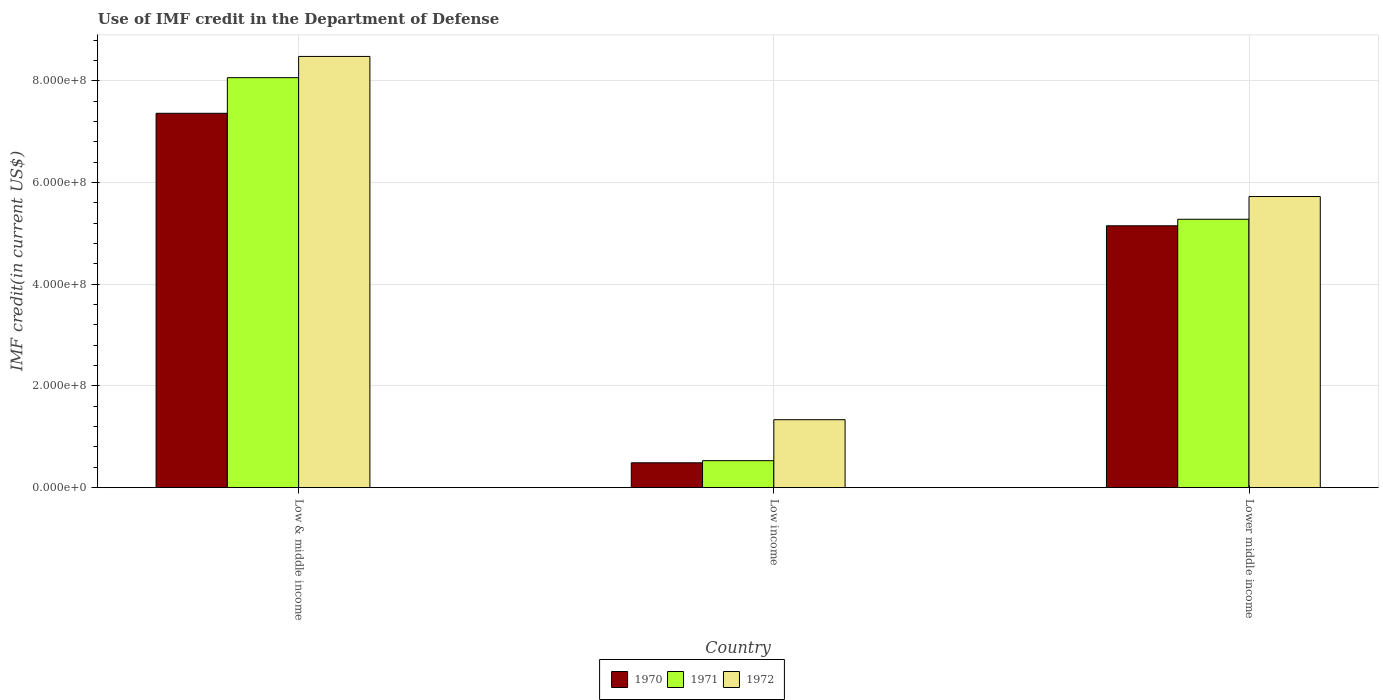Are the number of bars on each tick of the X-axis equal?
Your answer should be very brief. Yes. How many bars are there on the 3rd tick from the left?
Provide a short and direct response. 3. What is the label of the 1st group of bars from the left?
Make the answer very short. Low & middle income. In how many cases, is the number of bars for a given country not equal to the number of legend labels?
Provide a short and direct response. 0. What is the IMF credit in the Department of Defense in 1970 in Low income?
Keep it short and to the point. 4.88e+07. Across all countries, what is the maximum IMF credit in the Department of Defense in 1971?
Your response must be concise. 8.06e+08. Across all countries, what is the minimum IMF credit in the Department of Defense in 1972?
Your answer should be compact. 1.34e+08. In which country was the IMF credit in the Department of Defense in 1971 maximum?
Make the answer very short. Low & middle income. In which country was the IMF credit in the Department of Defense in 1970 minimum?
Ensure brevity in your answer.  Low income. What is the total IMF credit in the Department of Defense in 1972 in the graph?
Ensure brevity in your answer.  1.55e+09. What is the difference between the IMF credit in the Department of Defense in 1970 in Low & middle income and that in Lower middle income?
Offer a terse response. 2.21e+08. What is the difference between the IMF credit in the Department of Defense in 1971 in Low income and the IMF credit in the Department of Defense in 1970 in Low & middle income?
Your answer should be compact. -6.83e+08. What is the average IMF credit in the Department of Defense in 1972 per country?
Make the answer very short. 5.18e+08. What is the difference between the IMF credit in the Department of Defense of/in 1971 and IMF credit in the Department of Defense of/in 1972 in Low & middle income?
Your answer should be compact. -4.18e+07. What is the ratio of the IMF credit in the Department of Defense in 1970 in Low income to that in Lower middle income?
Your response must be concise. 0.09. Is the IMF credit in the Department of Defense in 1971 in Low income less than that in Lower middle income?
Keep it short and to the point. Yes. Is the difference between the IMF credit in the Department of Defense in 1971 in Low income and Lower middle income greater than the difference between the IMF credit in the Department of Defense in 1972 in Low income and Lower middle income?
Keep it short and to the point. No. What is the difference between the highest and the second highest IMF credit in the Department of Defense in 1972?
Ensure brevity in your answer.  -7.14e+08. What is the difference between the highest and the lowest IMF credit in the Department of Defense in 1970?
Give a very brief answer. 6.87e+08. In how many countries, is the IMF credit in the Department of Defense in 1970 greater than the average IMF credit in the Department of Defense in 1970 taken over all countries?
Give a very brief answer. 2. Is the sum of the IMF credit in the Department of Defense in 1970 in Low income and Lower middle income greater than the maximum IMF credit in the Department of Defense in 1972 across all countries?
Your answer should be compact. No. What does the 2nd bar from the right in Lower middle income represents?
Offer a terse response. 1971. Are all the bars in the graph horizontal?
Keep it short and to the point. No. Are the values on the major ticks of Y-axis written in scientific E-notation?
Give a very brief answer. Yes. Does the graph contain any zero values?
Offer a terse response. No. Where does the legend appear in the graph?
Your answer should be very brief. Bottom center. What is the title of the graph?
Provide a succinct answer. Use of IMF credit in the Department of Defense. What is the label or title of the Y-axis?
Keep it short and to the point. IMF credit(in current US$). What is the IMF credit(in current US$) in 1970 in Low & middle income?
Offer a terse response. 7.36e+08. What is the IMF credit(in current US$) in 1971 in Low & middle income?
Offer a very short reply. 8.06e+08. What is the IMF credit(in current US$) of 1972 in Low & middle income?
Your answer should be very brief. 8.48e+08. What is the IMF credit(in current US$) in 1970 in Low income?
Offer a terse response. 4.88e+07. What is the IMF credit(in current US$) of 1971 in Low income?
Keep it short and to the point. 5.30e+07. What is the IMF credit(in current US$) of 1972 in Low income?
Ensure brevity in your answer.  1.34e+08. What is the IMF credit(in current US$) of 1970 in Lower middle income?
Your answer should be compact. 5.15e+08. What is the IMF credit(in current US$) of 1971 in Lower middle income?
Give a very brief answer. 5.28e+08. What is the IMF credit(in current US$) of 1972 in Lower middle income?
Offer a terse response. 5.73e+08. Across all countries, what is the maximum IMF credit(in current US$) in 1970?
Ensure brevity in your answer.  7.36e+08. Across all countries, what is the maximum IMF credit(in current US$) of 1971?
Provide a succinct answer. 8.06e+08. Across all countries, what is the maximum IMF credit(in current US$) of 1972?
Your answer should be very brief. 8.48e+08. Across all countries, what is the minimum IMF credit(in current US$) of 1970?
Offer a terse response. 4.88e+07. Across all countries, what is the minimum IMF credit(in current US$) of 1971?
Your answer should be compact. 5.30e+07. Across all countries, what is the minimum IMF credit(in current US$) of 1972?
Your answer should be compact. 1.34e+08. What is the total IMF credit(in current US$) of 1970 in the graph?
Ensure brevity in your answer.  1.30e+09. What is the total IMF credit(in current US$) of 1971 in the graph?
Provide a succinct answer. 1.39e+09. What is the total IMF credit(in current US$) in 1972 in the graph?
Provide a succinct answer. 1.55e+09. What is the difference between the IMF credit(in current US$) of 1970 in Low & middle income and that in Low income?
Your answer should be very brief. 6.87e+08. What is the difference between the IMF credit(in current US$) in 1971 in Low & middle income and that in Low income?
Keep it short and to the point. 7.53e+08. What is the difference between the IMF credit(in current US$) of 1972 in Low & middle income and that in Low income?
Offer a terse response. 7.14e+08. What is the difference between the IMF credit(in current US$) in 1970 in Low & middle income and that in Lower middle income?
Make the answer very short. 2.21e+08. What is the difference between the IMF credit(in current US$) of 1971 in Low & middle income and that in Lower middle income?
Provide a short and direct response. 2.79e+08. What is the difference between the IMF credit(in current US$) of 1972 in Low & middle income and that in Lower middle income?
Ensure brevity in your answer.  2.76e+08. What is the difference between the IMF credit(in current US$) of 1970 in Low income and that in Lower middle income?
Your response must be concise. -4.66e+08. What is the difference between the IMF credit(in current US$) of 1971 in Low income and that in Lower middle income?
Your answer should be compact. -4.75e+08. What is the difference between the IMF credit(in current US$) of 1972 in Low income and that in Lower middle income?
Give a very brief answer. -4.39e+08. What is the difference between the IMF credit(in current US$) in 1970 in Low & middle income and the IMF credit(in current US$) in 1971 in Low income?
Keep it short and to the point. 6.83e+08. What is the difference between the IMF credit(in current US$) of 1970 in Low & middle income and the IMF credit(in current US$) of 1972 in Low income?
Your answer should be very brief. 6.03e+08. What is the difference between the IMF credit(in current US$) in 1971 in Low & middle income and the IMF credit(in current US$) in 1972 in Low income?
Your response must be concise. 6.73e+08. What is the difference between the IMF credit(in current US$) of 1970 in Low & middle income and the IMF credit(in current US$) of 1971 in Lower middle income?
Make the answer very short. 2.08e+08. What is the difference between the IMF credit(in current US$) in 1970 in Low & middle income and the IMF credit(in current US$) in 1972 in Lower middle income?
Keep it short and to the point. 1.64e+08. What is the difference between the IMF credit(in current US$) in 1971 in Low & middle income and the IMF credit(in current US$) in 1972 in Lower middle income?
Ensure brevity in your answer.  2.34e+08. What is the difference between the IMF credit(in current US$) in 1970 in Low income and the IMF credit(in current US$) in 1971 in Lower middle income?
Keep it short and to the point. -4.79e+08. What is the difference between the IMF credit(in current US$) of 1970 in Low income and the IMF credit(in current US$) of 1972 in Lower middle income?
Ensure brevity in your answer.  -5.24e+08. What is the difference between the IMF credit(in current US$) in 1971 in Low income and the IMF credit(in current US$) in 1972 in Lower middle income?
Offer a terse response. -5.20e+08. What is the average IMF credit(in current US$) in 1970 per country?
Keep it short and to the point. 4.33e+08. What is the average IMF credit(in current US$) of 1971 per country?
Provide a succinct answer. 4.62e+08. What is the average IMF credit(in current US$) of 1972 per country?
Your answer should be compact. 5.18e+08. What is the difference between the IMF credit(in current US$) of 1970 and IMF credit(in current US$) of 1971 in Low & middle income?
Your answer should be very brief. -7.00e+07. What is the difference between the IMF credit(in current US$) of 1970 and IMF credit(in current US$) of 1972 in Low & middle income?
Give a very brief answer. -1.12e+08. What is the difference between the IMF credit(in current US$) in 1971 and IMF credit(in current US$) in 1972 in Low & middle income?
Keep it short and to the point. -4.18e+07. What is the difference between the IMF credit(in current US$) of 1970 and IMF credit(in current US$) of 1971 in Low income?
Your answer should be very brief. -4.21e+06. What is the difference between the IMF credit(in current US$) in 1970 and IMF credit(in current US$) in 1972 in Low income?
Provide a short and direct response. -8.47e+07. What is the difference between the IMF credit(in current US$) of 1971 and IMF credit(in current US$) of 1972 in Low income?
Offer a terse response. -8.05e+07. What is the difference between the IMF credit(in current US$) of 1970 and IMF credit(in current US$) of 1971 in Lower middle income?
Your answer should be very brief. -1.28e+07. What is the difference between the IMF credit(in current US$) in 1970 and IMF credit(in current US$) in 1972 in Lower middle income?
Offer a terse response. -5.76e+07. What is the difference between the IMF credit(in current US$) of 1971 and IMF credit(in current US$) of 1972 in Lower middle income?
Your answer should be compact. -4.48e+07. What is the ratio of the IMF credit(in current US$) of 1970 in Low & middle income to that in Low income?
Provide a short and direct response. 15.08. What is the ratio of the IMF credit(in current US$) in 1971 in Low & middle income to that in Low income?
Give a very brief answer. 15.21. What is the ratio of the IMF credit(in current US$) in 1972 in Low & middle income to that in Low income?
Give a very brief answer. 6.35. What is the ratio of the IMF credit(in current US$) of 1970 in Low & middle income to that in Lower middle income?
Keep it short and to the point. 1.43. What is the ratio of the IMF credit(in current US$) in 1971 in Low & middle income to that in Lower middle income?
Offer a very short reply. 1.53. What is the ratio of the IMF credit(in current US$) in 1972 in Low & middle income to that in Lower middle income?
Ensure brevity in your answer.  1.48. What is the ratio of the IMF credit(in current US$) in 1970 in Low income to that in Lower middle income?
Ensure brevity in your answer.  0.09. What is the ratio of the IMF credit(in current US$) of 1971 in Low income to that in Lower middle income?
Offer a very short reply. 0.1. What is the ratio of the IMF credit(in current US$) in 1972 in Low income to that in Lower middle income?
Your response must be concise. 0.23. What is the difference between the highest and the second highest IMF credit(in current US$) in 1970?
Your response must be concise. 2.21e+08. What is the difference between the highest and the second highest IMF credit(in current US$) in 1971?
Your answer should be compact. 2.79e+08. What is the difference between the highest and the second highest IMF credit(in current US$) in 1972?
Provide a short and direct response. 2.76e+08. What is the difference between the highest and the lowest IMF credit(in current US$) of 1970?
Your answer should be very brief. 6.87e+08. What is the difference between the highest and the lowest IMF credit(in current US$) in 1971?
Your answer should be very brief. 7.53e+08. What is the difference between the highest and the lowest IMF credit(in current US$) of 1972?
Your answer should be very brief. 7.14e+08. 